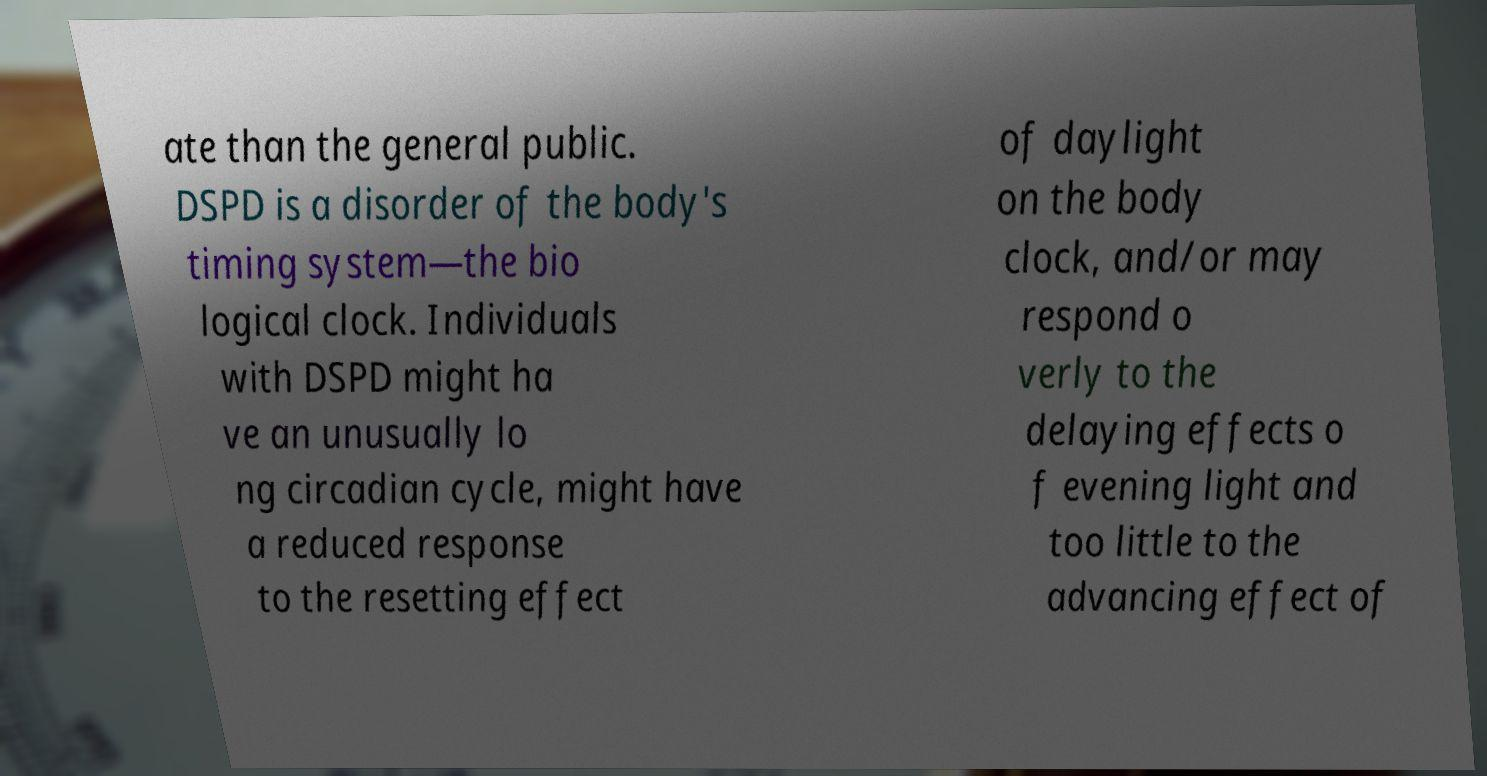Please identify and transcribe the text found in this image. ate than the general public. DSPD is a disorder of the body's timing system—the bio logical clock. Individuals with DSPD might ha ve an unusually lo ng circadian cycle, might have a reduced response to the resetting effect of daylight on the body clock, and/or may respond o verly to the delaying effects o f evening light and too little to the advancing effect of 